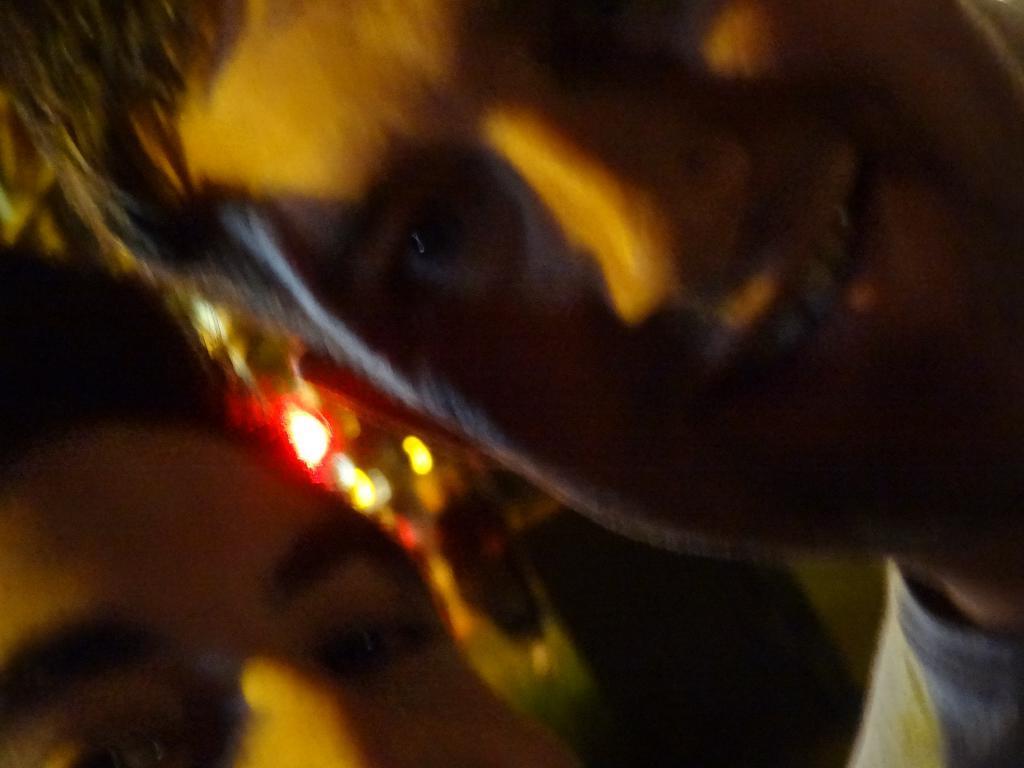Can you describe this image briefly? In this image, we can see two person and there are some lights. 